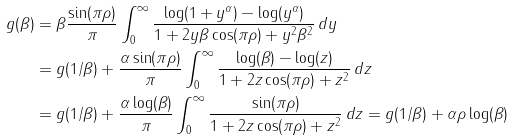<formula> <loc_0><loc_0><loc_500><loc_500>g ( \beta ) & = \beta \frac { \sin ( \pi \rho ) } { \pi } \int _ { 0 } ^ { \infty } \frac { \log ( 1 + y ^ { \alpha } ) - \log ( y ^ { \alpha } ) } { 1 + 2 y \beta \cos ( \pi \rho ) + y ^ { 2 } \beta ^ { 2 } } \, d y \\ & = g ( 1 / \beta ) + \frac { \alpha \sin ( \pi \rho ) } { \pi } \int _ { 0 } ^ { \infty } \frac { \log ( \beta ) - \log ( z ) } { 1 + 2 z \cos ( \pi \rho ) + z ^ { 2 } } \, d z \\ & = g ( 1 / \beta ) + \frac { \alpha \log ( \beta ) } { \pi } \int _ { 0 } ^ { \infty } \frac { \sin ( \pi \rho ) } { 1 + 2 z \cos ( \pi \rho ) + z ^ { 2 } } \, d z = g ( 1 / \beta ) + \alpha \rho \log ( \beta )</formula> 